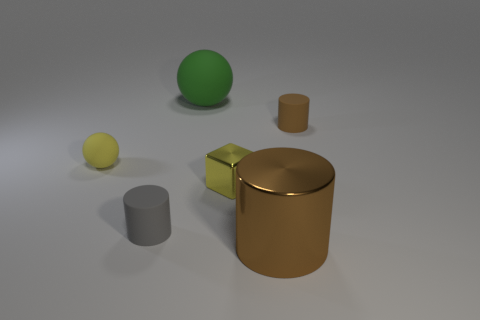Subtract all gray matte cylinders. How many cylinders are left? 2 Subtract all red blocks. How many brown cylinders are left? 2 Add 3 big metallic cylinders. How many objects exist? 9 Subtract all balls. How many objects are left? 4 Subtract 1 cylinders. How many cylinders are left? 2 Subtract all cyan cylinders. Subtract all green cubes. How many cylinders are left? 3 Add 4 tiny green cylinders. How many tiny green cylinders exist? 4 Subtract 0 red cubes. How many objects are left? 6 Subtract all brown metallic objects. Subtract all yellow balls. How many objects are left? 4 Add 5 tiny brown cylinders. How many tiny brown cylinders are left? 6 